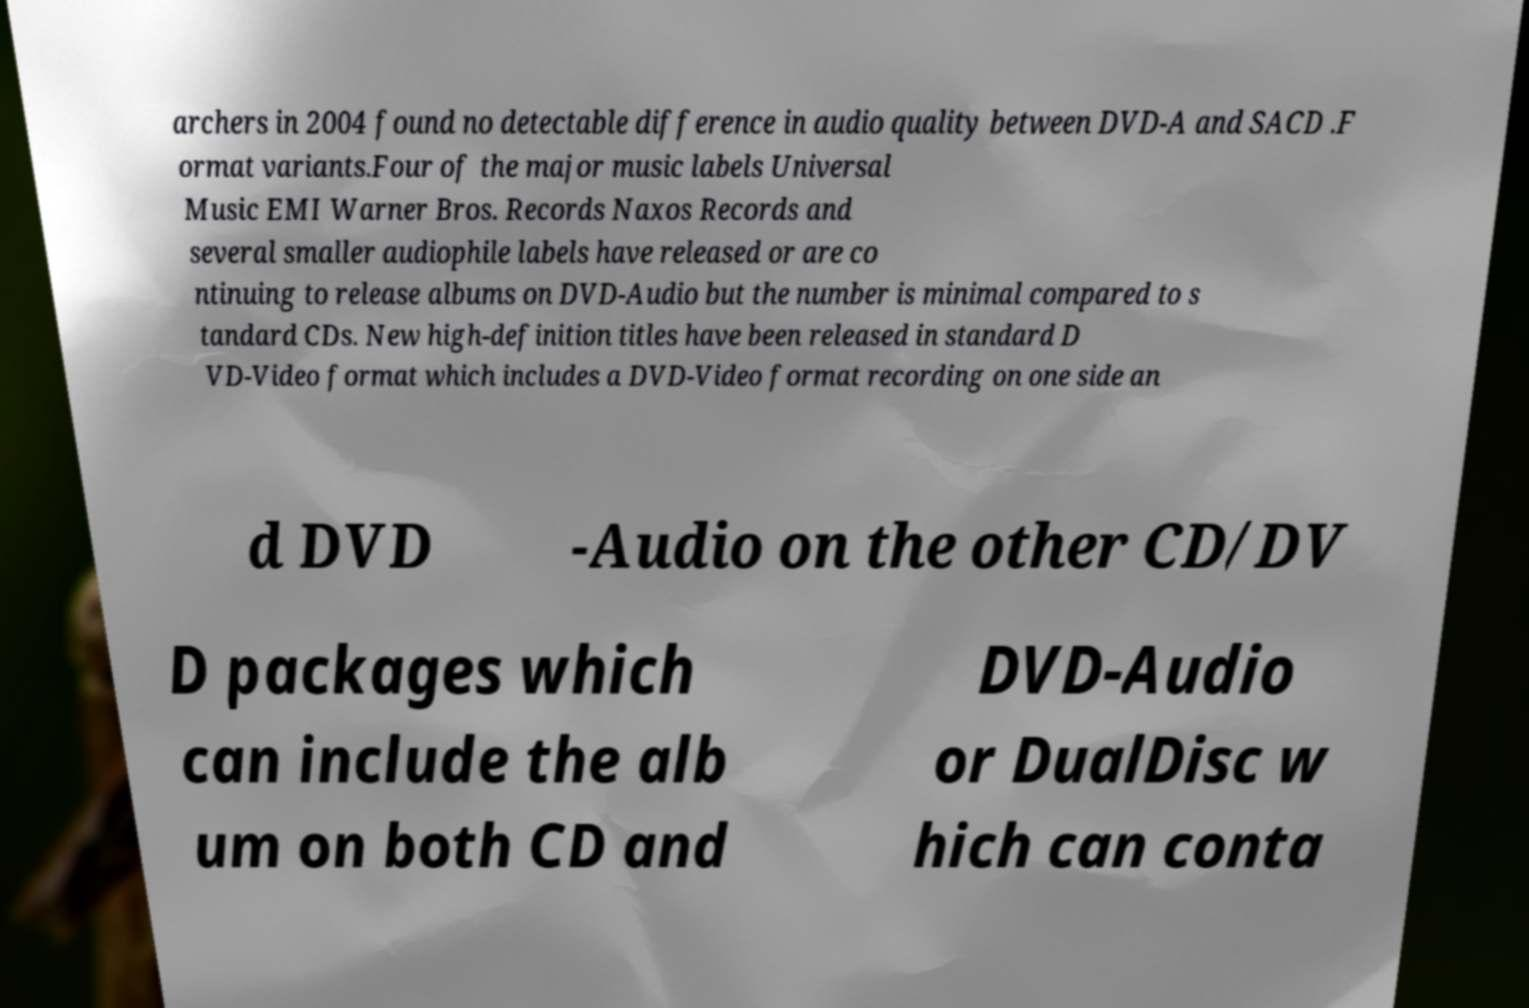For documentation purposes, I need the text within this image transcribed. Could you provide that? archers in 2004 found no detectable difference in audio quality between DVD-A and SACD .F ormat variants.Four of the major music labels Universal Music EMI Warner Bros. Records Naxos Records and several smaller audiophile labels have released or are co ntinuing to release albums on DVD-Audio but the number is minimal compared to s tandard CDs. New high-definition titles have been released in standard D VD-Video format which includes a DVD-Video format recording on one side an d DVD -Audio on the other CD/DV D packages which can include the alb um on both CD and DVD-Audio or DualDisc w hich can conta 